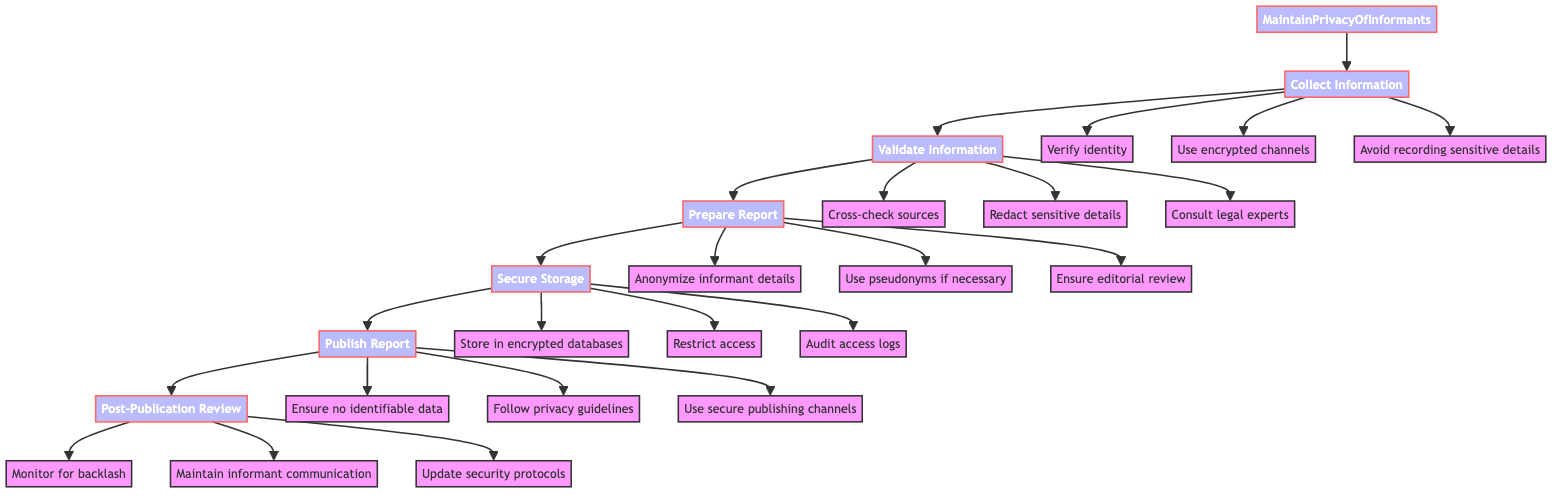What is the first step in the function? The first step in the flowchart indicates "Collect Information." This is depicted as the first node directly connected to the function's main node.
Answer: Collect Information How many steps are there in total? Counting all nodes in the flowchart starts from "Maintain Privacy of Informants" and includes six additional steps, resulting in seven nodes total.
Answer: 6 What action should be taken during the "Validate Information" step? One of the actions listed under "Validate Information" includes "Redact sensitive details that could reveal informant's identity." This indicates a specific preventive measure taken in that step.
Answer: Redact sensitive details Which action comes after "Prepare Report"? The flowchart indicates "Secure Storage" immediately follows "Prepare Report," making it the next required action to be performed in the function.
Answer: Secure Storage What is the last step in this function? The last step outlined in the flowchart is "Post-Publication Review," which is the final node following the previous steps.
Answer: Post-Publication Review Which step includes guidance from legal experts? The step that includes consulting legal experts is "Validate Information." It emphasizes the importance of legal compliance in verifying information shared by informants.
Answer: Validate Information Which action requires maintaining communication with the informant? The action under "Post-Publication Review" that addresses this need is "Maintain open communication with the informant," highlighting the ongoing relationship post-reporting.
Answer: Maintain open communication What is used to ensure anonymity in the "Prepare Report" step? In "Prepare Report," one of the key actions taken is to "Anonymize informant details" to protect their identity during the reporting process.
Answer: Anonymize informant details How should sensitive content be published according to the diagram? "Use secure channels to publish sensitive content" is the specified action under the "Publish Report" step, indicating the method by which sensitive material should be disseminated.
Answer: Use secure channels 